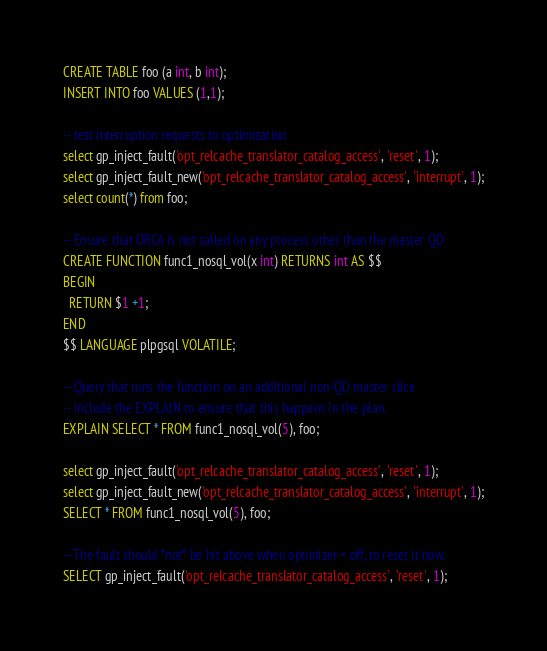<code> <loc_0><loc_0><loc_500><loc_500><_SQL_>CREATE TABLE foo (a int, b int);
INSERT INTO foo VALUES (1,1);

-- test interruption requests to optimization
select gp_inject_fault('opt_relcache_translator_catalog_access', 'reset', 1);
select gp_inject_fault_new('opt_relcache_translator_catalog_access', 'interrupt', 1);
select count(*) from foo;

-- Ensure that ORCA is not called on any process other than the master QD
CREATE FUNCTION func1_nosql_vol(x int) RETURNS int AS $$
BEGIN
  RETURN $1 +1;
END
$$ LANGUAGE plpgsql VOLATILE;

-- Query that runs the function on an additional non-QD master slice
-- Include the EXPLAIN to ensure that this happens in the plan.
EXPLAIN SELECT * FROM func1_nosql_vol(5), foo;

select gp_inject_fault('opt_relcache_translator_catalog_access', 'reset', 1);
select gp_inject_fault_new('opt_relcache_translator_catalog_access', 'interrupt', 1);
SELECT * FROM func1_nosql_vol(5), foo;

-- The fault should *not* be hit above when optimizer = off, to reset it now.
SELECT gp_inject_fault('opt_relcache_translator_catalog_access', 'reset', 1);
</code> 